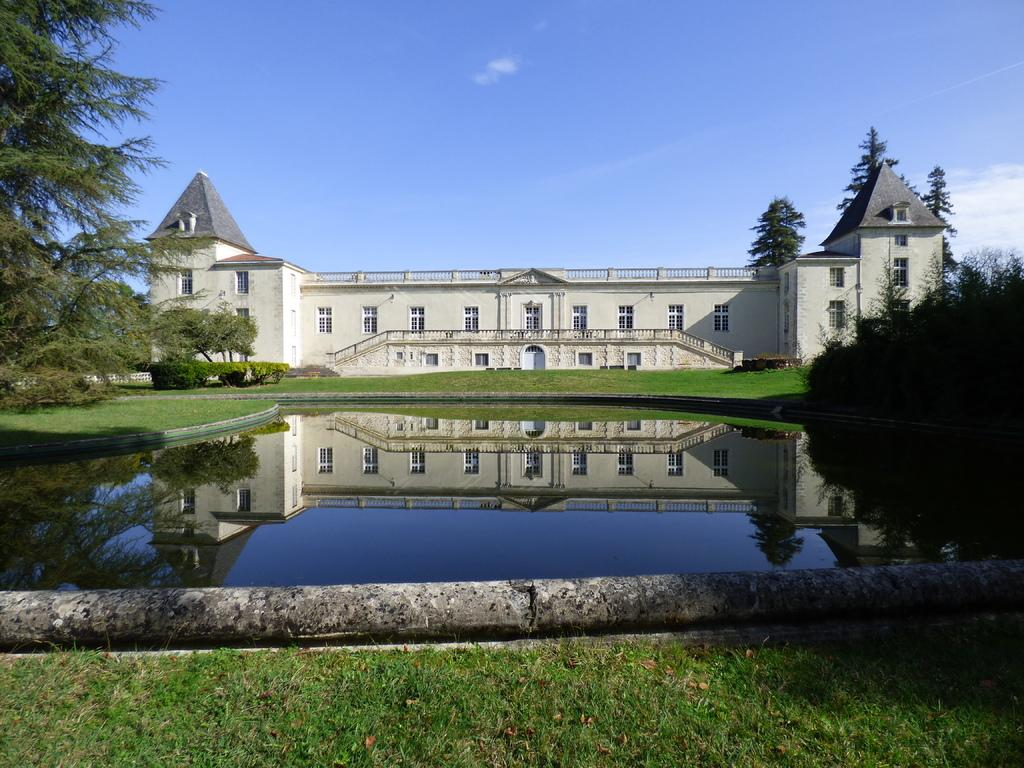What type of structure is present in the image? There is a building in the image. What feature can be seen on the building? The building has windows. What natural elements are visible in the image? Water, grass, and trees are visible in the image. What part of the environment can be seen in the image? The sky is visible in the image. What type of bone is being discussed by the people in the image? There are no people present in the image, and therefore no discussion or bones can be observed. 